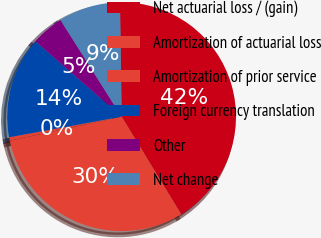Convert chart to OTSL. <chart><loc_0><loc_0><loc_500><loc_500><pie_chart><fcel>Net actuarial loss / (gain)<fcel>Amortization of actuarial loss<fcel>Amortization of prior service<fcel>Foreign currency translation<fcel>Other<fcel>Net change<nl><fcel>41.51%<fcel>30.35%<fcel>0.49%<fcel>14.32%<fcel>4.59%<fcel>8.74%<nl></chart> 